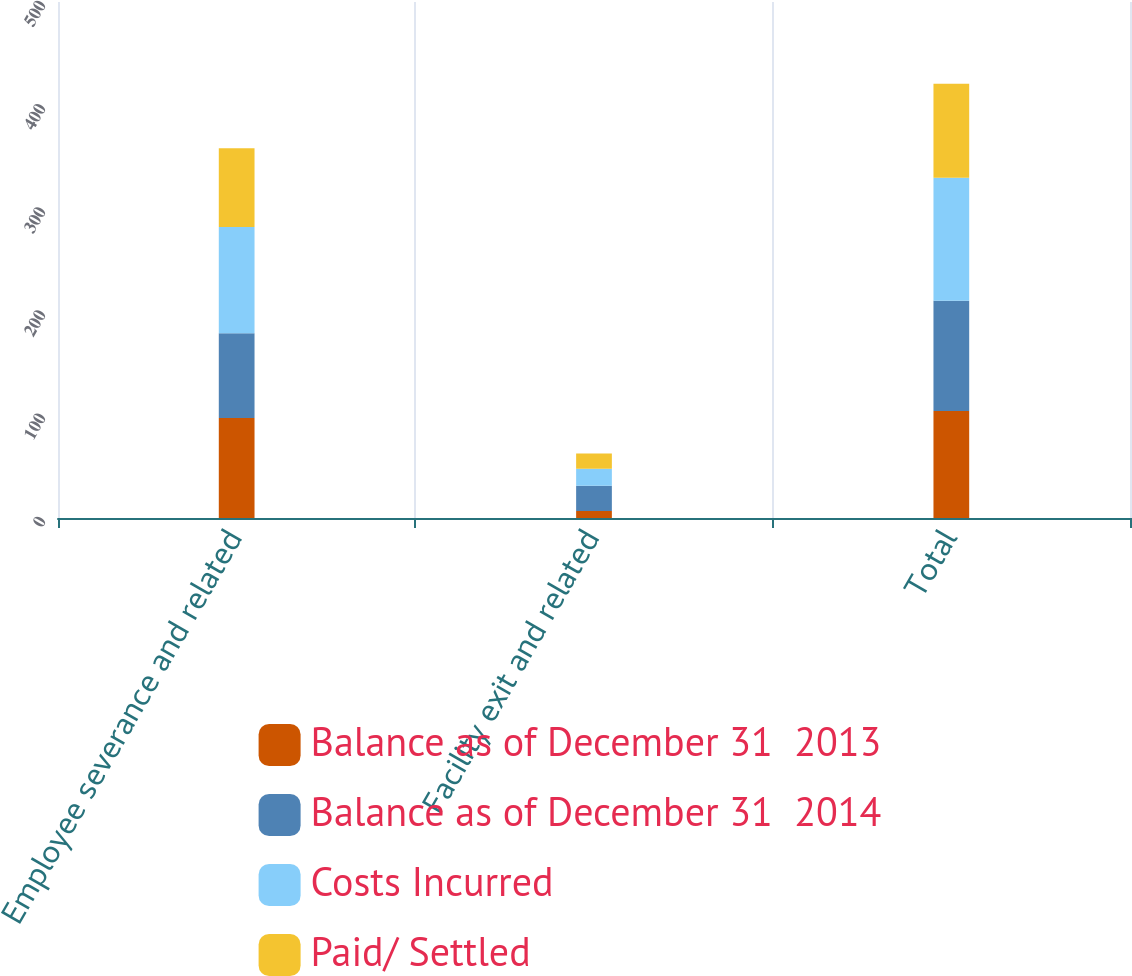Convert chart. <chart><loc_0><loc_0><loc_500><loc_500><stacked_bar_chart><ecel><fcel>Employee severance and related<fcel>Facility exit and related<fcel>Total<nl><fcel>Balance as of December 31  2013<fcel>96.9<fcel>6.8<fcel>103.7<nl><fcel>Balance as of December 31  2014<fcel>82.2<fcel>24.5<fcel>106.7<nl><fcel>Costs Incurred<fcel>102.8<fcel>16.4<fcel>119.2<nl><fcel>Paid/ Settled<fcel>76.3<fcel>14.9<fcel>91.2<nl></chart> 